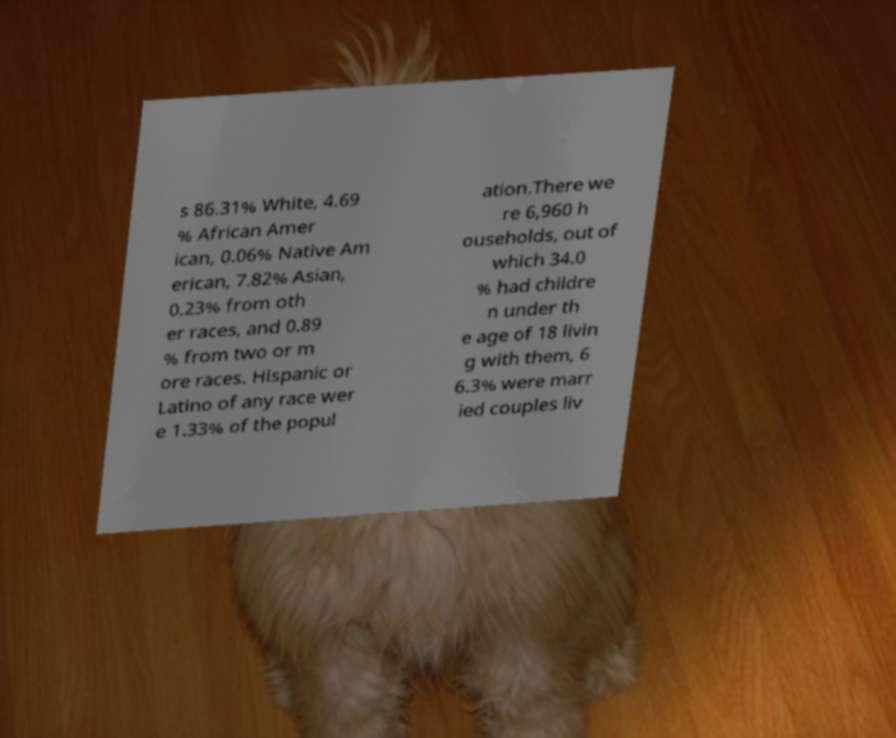Can you read and provide the text displayed in the image?This photo seems to have some interesting text. Can you extract and type it out for me? s 86.31% White, 4.69 % African Amer ican, 0.06% Native Am erican, 7.82% Asian, 0.23% from oth er races, and 0.89 % from two or m ore races. Hispanic or Latino of any race wer e 1.33% of the popul ation.There we re 6,960 h ouseholds, out of which 34.0 % had childre n under th e age of 18 livin g with them, 6 6.3% were marr ied couples liv 